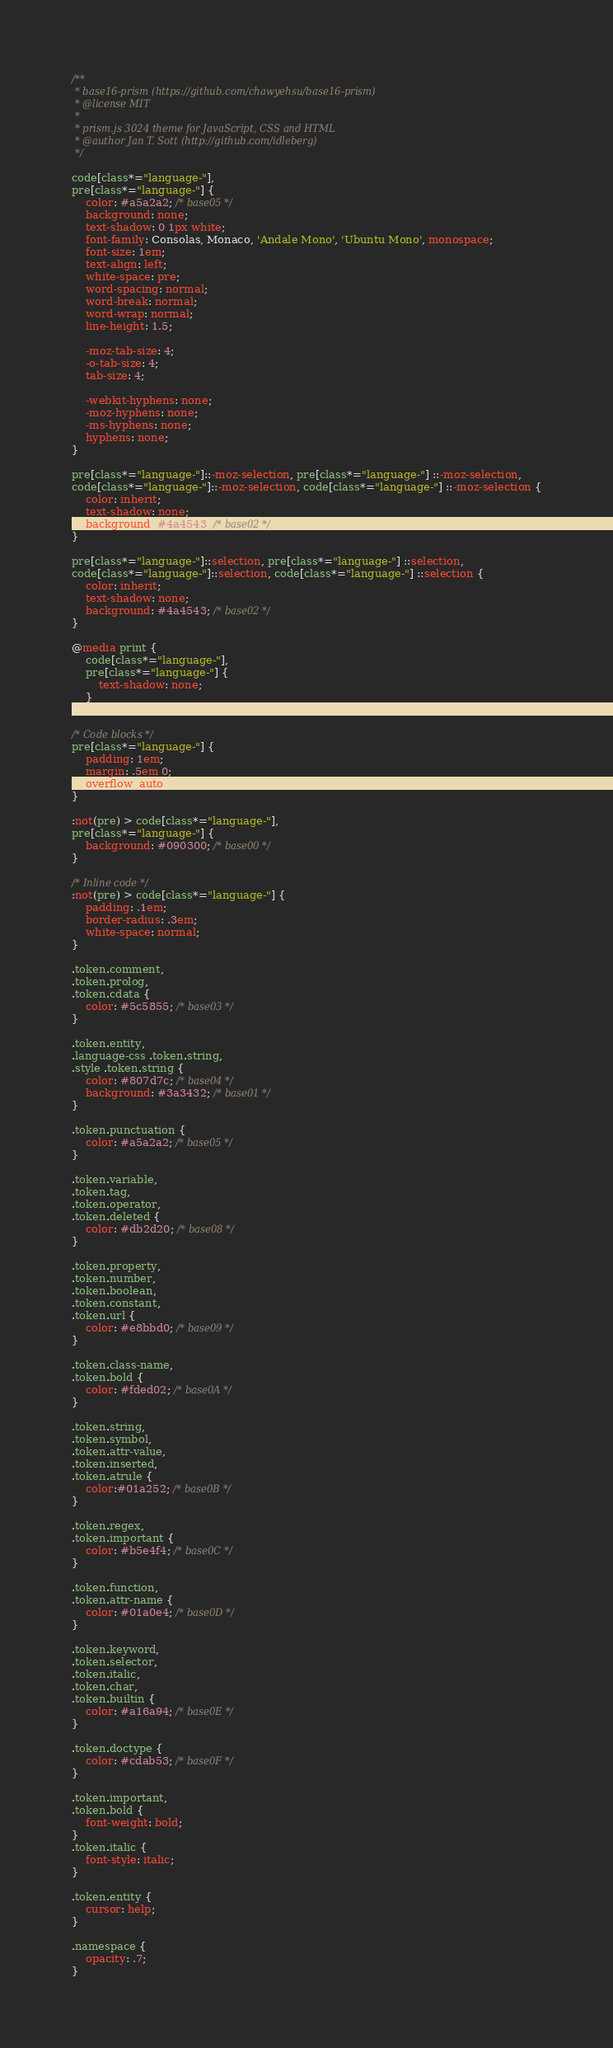<code> <loc_0><loc_0><loc_500><loc_500><_CSS_>/**
 * base16-prism (https://github.com/chawyehsu/base16-prism)
 * @license MIT
 *
 * prism.js 3024 theme for JavaScript, CSS and HTML
 * @author Jan T. Sott (http://github.com/idleberg)
 */

code[class*="language-"],
pre[class*="language-"] {
    color: #a5a2a2; /* base05 */
    background: none;
    text-shadow: 0 1px white;
    font-family: Consolas, Monaco, 'Andale Mono', 'Ubuntu Mono', monospace;
    font-size: 1em;
    text-align: left;
    white-space: pre;
    word-spacing: normal;
    word-break: normal;
    word-wrap: normal;
    line-height: 1.5;

    -moz-tab-size: 4;
    -o-tab-size: 4;
    tab-size: 4;

    -webkit-hyphens: none;
    -moz-hyphens: none;
    -ms-hyphens: none;
    hyphens: none;
}

pre[class*="language-"]::-moz-selection, pre[class*="language-"] ::-moz-selection,
code[class*="language-"]::-moz-selection, code[class*="language-"] ::-moz-selection {
    color: inherit;
    text-shadow: none;
    background: #4a4543; /* base02 */
}

pre[class*="language-"]::selection, pre[class*="language-"] ::selection,
code[class*="language-"]::selection, code[class*="language-"] ::selection {
    color: inherit;
    text-shadow: none;
    background: #4a4543; /* base02 */
}

@media print {
    code[class*="language-"],
    pre[class*="language-"] {
        text-shadow: none;
    }
}

/* Code blocks */
pre[class*="language-"] {
    padding: 1em;
    margin: .5em 0;
    overflow: auto;
}

:not(pre) > code[class*="language-"],
pre[class*="language-"] {
    background: #090300; /* base00 */
}

/* Inline code */
:not(pre) > code[class*="language-"] {
    padding: .1em;
    border-radius: .3em;
    white-space: normal;
}

.token.comment,
.token.prolog,
.token.cdata {
    color: #5c5855; /* base03 */
}

.token.entity,
.language-css .token.string,
.style .token.string {
    color: #807d7c; /* base04 */
    background: #3a3432; /* base01 */
}

.token.punctuation {
    color: #a5a2a2; /* base05 */
}

.token.variable,
.token.tag,
.token.operator,
.token.deleted {
    color: #db2d20; /* base08 */
}

.token.property,
.token.number,
.token.boolean,
.token.constant,
.token.url {
    color: #e8bbd0; /* base09 */
}

.token.class-name,
.token.bold {
    color: #fded02; /* base0A */
}

.token.string,
.token.symbol,
.token.attr-value,
.token.inserted,
.token.atrule {
    color:#01a252; /* base0B */
}

.token.regex,
.token.important {
    color: #b5e4f4; /* base0C */
}

.token.function,
.token.attr-name {
    color: #01a0e4; /* base0D */
}

.token.keyword,
.token.selector,
.token.italic,
.token.char,
.token.builtin {
    color: #a16a94; /* base0E */
}

.token.doctype {
    color: #cdab53; /* base0F */
}

.token.important,
.token.bold {
    font-weight: bold;
}
.token.italic {
    font-style: italic;
}

.token.entity {
    cursor: help;
}

.namespace {
    opacity: .7;
}
</code> 